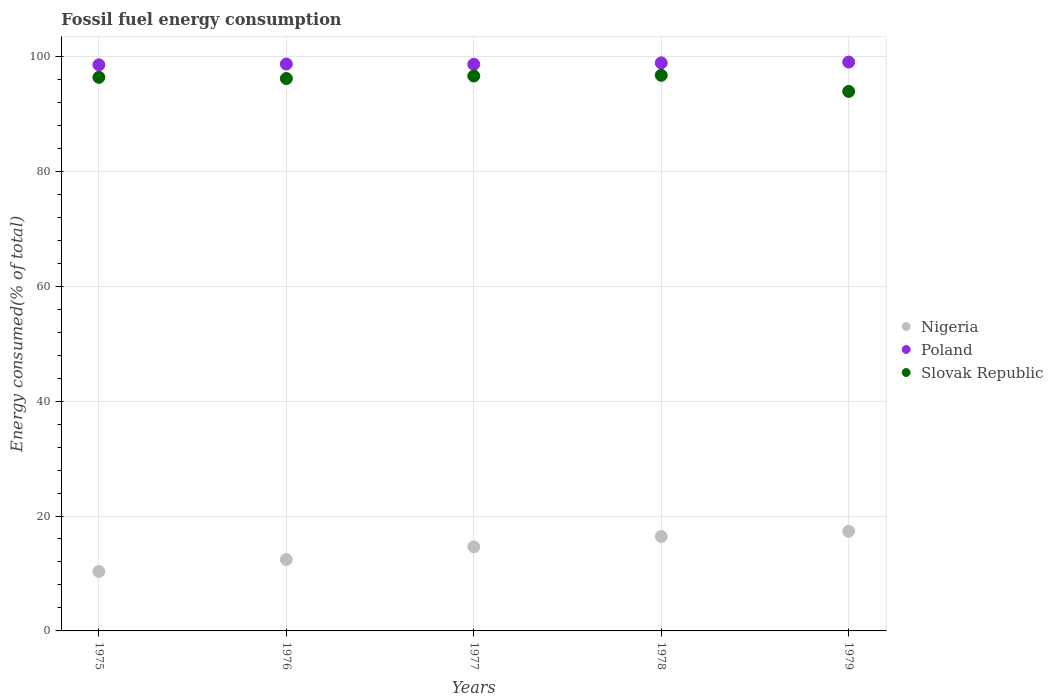How many different coloured dotlines are there?
Your response must be concise. 3. What is the percentage of energy consumed in Nigeria in 1976?
Your answer should be very brief. 12.43. Across all years, what is the maximum percentage of energy consumed in Poland?
Offer a terse response. 99.01. Across all years, what is the minimum percentage of energy consumed in Poland?
Provide a short and direct response. 98.53. In which year was the percentage of energy consumed in Poland maximum?
Offer a terse response. 1979. In which year was the percentage of energy consumed in Poland minimum?
Provide a succinct answer. 1975. What is the total percentage of energy consumed in Poland in the graph?
Give a very brief answer. 493.68. What is the difference between the percentage of energy consumed in Nigeria in 1978 and that in 1979?
Provide a short and direct response. -0.9. What is the difference between the percentage of energy consumed in Poland in 1975 and the percentage of energy consumed in Slovak Republic in 1976?
Your response must be concise. 2.39. What is the average percentage of energy consumed in Slovak Republic per year?
Offer a terse response. 95.93. In the year 1978, what is the difference between the percentage of energy consumed in Slovak Republic and percentage of energy consumed in Poland?
Your answer should be very brief. -2.16. In how many years, is the percentage of energy consumed in Poland greater than 80 %?
Provide a succinct answer. 5. What is the ratio of the percentage of energy consumed in Nigeria in 1975 to that in 1979?
Provide a short and direct response. 0.6. Is the difference between the percentage of energy consumed in Slovak Republic in 1975 and 1978 greater than the difference between the percentage of energy consumed in Poland in 1975 and 1978?
Keep it short and to the point. No. What is the difference between the highest and the second highest percentage of energy consumed in Nigeria?
Your answer should be compact. 0.9. What is the difference between the highest and the lowest percentage of energy consumed in Nigeria?
Offer a terse response. 6.98. Is the sum of the percentage of energy consumed in Slovak Republic in 1975 and 1976 greater than the maximum percentage of energy consumed in Poland across all years?
Keep it short and to the point. Yes. Is the percentage of energy consumed in Slovak Republic strictly greater than the percentage of energy consumed in Nigeria over the years?
Keep it short and to the point. Yes. How many dotlines are there?
Your answer should be very brief. 3. Where does the legend appear in the graph?
Provide a short and direct response. Center right. How many legend labels are there?
Your answer should be compact. 3. What is the title of the graph?
Your answer should be compact. Fossil fuel energy consumption. What is the label or title of the Y-axis?
Your answer should be compact. Energy consumed(% of total). What is the Energy consumed(% of total) in Nigeria in 1975?
Your response must be concise. 10.35. What is the Energy consumed(% of total) of Poland in 1975?
Your answer should be compact. 98.53. What is the Energy consumed(% of total) of Slovak Republic in 1975?
Keep it short and to the point. 96.35. What is the Energy consumed(% of total) of Nigeria in 1976?
Your answer should be compact. 12.43. What is the Energy consumed(% of total) of Poland in 1976?
Your answer should be compact. 98.66. What is the Energy consumed(% of total) in Slovak Republic in 1976?
Your response must be concise. 96.14. What is the Energy consumed(% of total) in Nigeria in 1977?
Offer a very short reply. 14.64. What is the Energy consumed(% of total) of Poland in 1977?
Your answer should be very brief. 98.62. What is the Energy consumed(% of total) of Slovak Republic in 1977?
Your response must be concise. 96.57. What is the Energy consumed(% of total) of Nigeria in 1978?
Your response must be concise. 16.44. What is the Energy consumed(% of total) in Poland in 1978?
Keep it short and to the point. 98.86. What is the Energy consumed(% of total) of Slovak Republic in 1978?
Your answer should be very brief. 96.7. What is the Energy consumed(% of total) in Nigeria in 1979?
Keep it short and to the point. 17.33. What is the Energy consumed(% of total) in Poland in 1979?
Make the answer very short. 99.01. What is the Energy consumed(% of total) in Slovak Republic in 1979?
Keep it short and to the point. 93.9. Across all years, what is the maximum Energy consumed(% of total) of Nigeria?
Offer a terse response. 17.33. Across all years, what is the maximum Energy consumed(% of total) in Poland?
Your answer should be compact. 99.01. Across all years, what is the maximum Energy consumed(% of total) of Slovak Republic?
Ensure brevity in your answer.  96.7. Across all years, what is the minimum Energy consumed(% of total) of Nigeria?
Offer a terse response. 10.35. Across all years, what is the minimum Energy consumed(% of total) of Poland?
Offer a terse response. 98.53. Across all years, what is the minimum Energy consumed(% of total) of Slovak Republic?
Provide a short and direct response. 93.9. What is the total Energy consumed(% of total) in Nigeria in the graph?
Your answer should be very brief. 71.19. What is the total Energy consumed(% of total) in Poland in the graph?
Provide a short and direct response. 493.68. What is the total Energy consumed(% of total) in Slovak Republic in the graph?
Make the answer very short. 479.66. What is the difference between the Energy consumed(% of total) of Nigeria in 1975 and that in 1976?
Keep it short and to the point. -2.08. What is the difference between the Energy consumed(% of total) in Poland in 1975 and that in 1976?
Keep it short and to the point. -0.13. What is the difference between the Energy consumed(% of total) in Slovak Republic in 1975 and that in 1976?
Your answer should be compact. 0.21. What is the difference between the Energy consumed(% of total) of Nigeria in 1975 and that in 1977?
Offer a very short reply. -4.29. What is the difference between the Energy consumed(% of total) of Poland in 1975 and that in 1977?
Provide a short and direct response. -0.09. What is the difference between the Energy consumed(% of total) of Slovak Republic in 1975 and that in 1977?
Offer a terse response. -0.23. What is the difference between the Energy consumed(% of total) of Nigeria in 1975 and that in 1978?
Keep it short and to the point. -6.09. What is the difference between the Energy consumed(% of total) in Poland in 1975 and that in 1978?
Give a very brief answer. -0.33. What is the difference between the Energy consumed(% of total) of Slovak Republic in 1975 and that in 1978?
Your response must be concise. -0.36. What is the difference between the Energy consumed(% of total) of Nigeria in 1975 and that in 1979?
Give a very brief answer. -6.98. What is the difference between the Energy consumed(% of total) of Poland in 1975 and that in 1979?
Your answer should be very brief. -0.48. What is the difference between the Energy consumed(% of total) in Slovak Republic in 1975 and that in 1979?
Offer a terse response. 2.45. What is the difference between the Energy consumed(% of total) of Nigeria in 1976 and that in 1977?
Give a very brief answer. -2.21. What is the difference between the Energy consumed(% of total) in Poland in 1976 and that in 1977?
Your response must be concise. 0.05. What is the difference between the Energy consumed(% of total) in Slovak Republic in 1976 and that in 1977?
Your answer should be very brief. -0.43. What is the difference between the Energy consumed(% of total) of Nigeria in 1976 and that in 1978?
Make the answer very short. -4.01. What is the difference between the Energy consumed(% of total) in Poland in 1976 and that in 1978?
Ensure brevity in your answer.  -0.2. What is the difference between the Energy consumed(% of total) of Slovak Republic in 1976 and that in 1978?
Offer a terse response. -0.56. What is the difference between the Energy consumed(% of total) in Nigeria in 1976 and that in 1979?
Keep it short and to the point. -4.91. What is the difference between the Energy consumed(% of total) of Poland in 1976 and that in 1979?
Offer a very short reply. -0.35. What is the difference between the Energy consumed(% of total) in Slovak Republic in 1976 and that in 1979?
Offer a terse response. 2.24. What is the difference between the Energy consumed(% of total) of Nigeria in 1977 and that in 1978?
Ensure brevity in your answer.  -1.8. What is the difference between the Energy consumed(% of total) of Poland in 1977 and that in 1978?
Your answer should be very brief. -0.24. What is the difference between the Energy consumed(% of total) of Slovak Republic in 1977 and that in 1978?
Ensure brevity in your answer.  -0.13. What is the difference between the Energy consumed(% of total) of Nigeria in 1977 and that in 1979?
Make the answer very short. -2.7. What is the difference between the Energy consumed(% of total) in Poland in 1977 and that in 1979?
Offer a terse response. -0.39. What is the difference between the Energy consumed(% of total) of Slovak Republic in 1977 and that in 1979?
Ensure brevity in your answer.  2.68. What is the difference between the Energy consumed(% of total) of Nigeria in 1978 and that in 1979?
Your response must be concise. -0.9. What is the difference between the Energy consumed(% of total) of Poland in 1978 and that in 1979?
Offer a very short reply. -0.15. What is the difference between the Energy consumed(% of total) of Slovak Republic in 1978 and that in 1979?
Give a very brief answer. 2.81. What is the difference between the Energy consumed(% of total) in Nigeria in 1975 and the Energy consumed(% of total) in Poland in 1976?
Offer a very short reply. -88.31. What is the difference between the Energy consumed(% of total) of Nigeria in 1975 and the Energy consumed(% of total) of Slovak Republic in 1976?
Offer a terse response. -85.79. What is the difference between the Energy consumed(% of total) of Poland in 1975 and the Energy consumed(% of total) of Slovak Republic in 1976?
Give a very brief answer. 2.39. What is the difference between the Energy consumed(% of total) in Nigeria in 1975 and the Energy consumed(% of total) in Poland in 1977?
Provide a succinct answer. -88.27. What is the difference between the Energy consumed(% of total) of Nigeria in 1975 and the Energy consumed(% of total) of Slovak Republic in 1977?
Keep it short and to the point. -86.22. What is the difference between the Energy consumed(% of total) in Poland in 1975 and the Energy consumed(% of total) in Slovak Republic in 1977?
Make the answer very short. 1.96. What is the difference between the Energy consumed(% of total) of Nigeria in 1975 and the Energy consumed(% of total) of Poland in 1978?
Provide a short and direct response. -88.51. What is the difference between the Energy consumed(% of total) in Nigeria in 1975 and the Energy consumed(% of total) in Slovak Republic in 1978?
Keep it short and to the point. -86.35. What is the difference between the Energy consumed(% of total) of Poland in 1975 and the Energy consumed(% of total) of Slovak Republic in 1978?
Your answer should be compact. 1.83. What is the difference between the Energy consumed(% of total) of Nigeria in 1975 and the Energy consumed(% of total) of Poland in 1979?
Provide a short and direct response. -88.66. What is the difference between the Energy consumed(% of total) in Nigeria in 1975 and the Energy consumed(% of total) in Slovak Republic in 1979?
Ensure brevity in your answer.  -83.55. What is the difference between the Energy consumed(% of total) of Poland in 1975 and the Energy consumed(% of total) of Slovak Republic in 1979?
Provide a short and direct response. 4.63. What is the difference between the Energy consumed(% of total) of Nigeria in 1976 and the Energy consumed(% of total) of Poland in 1977?
Offer a very short reply. -86.19. What is the difference between the Energy consumed(% of total) in Nigeria in 1976 and the Energy consumed(% of total) in Slovak Republic in 1977?
Your answer should be very brief. -84.15. What is the difference between the Energy consumed(% of total) in Poland in 1976 and the Energy consumed(% of total) in Slovak Republic in 1977?
Your answer should be very brief. 2.09. What is the difference between the Energy consumed(% of total) in Nigeria in 1976 and the Energy consumed(% of total) in Poland in 1978?
Your answer should be compact. -86.44. What is the difference between the Energy consumed(% of total) of Nigeria in 1976 and the Energy consumed(% of total) of Slovak Republic in 1978?
Provide a succinct answer. -84.28. What is the difference between the Energy consumed(% of total) of Poland in 1976 and the Energy consumed(% of total) of Slovak Republic in 1978?
Offer a terse response. 1.96. What is the difference between the Energy consumed(% of total) in Nigeria in 1976 and the Energy consumed(% of total) in Poland in 1979?
Ensure brevity in your answer.  -86.58. What is the difference between the Energy consumed(% of total) in Nigeria in 1976 and the Energy consumed(% of total) in Slovak Republic in 1979?
Your answer should be compact. -81.47. What is the difference between the Energy consumed(% of total) of Poland in 1976 and the Energy consumed(% of total) of Slovak Republic in 1979?
Offer a very short reply. 4.77. What is the difference between the Energy consumed(% of total) in Nigeria in 1977 and the Energy consumed(% of total) in Poland in 1978?
Keep it short and to the point. -84.22. What is the difference between the Energy consumed(% of total) in Nigeria in 1977 and the Energy consumed(% of total) in Slovak Republic in 1978?
Your answer should be very brief. -82.07. What is the difference between the Energy consumed(% of total) in Poland in 1977 and the Energy consumed(% of total) in Slovak Republic in 1978?
Your answer should be compact. 1.91. What is the difference between the Energy consumed(% of total) in Nigeria in 1977 and the Energy consumed(% of total) in Poland in 1979?
Keep it short and to the point. -84.37. What is the difference between the Energy consumed(% of total) in Nigeria in 1977 and the Energy consumed(% of total) in Slovak Republic in 1979?
Ensure brevity in your answer.  -79.26. What is the difference between the Energy consumed(% of total) in Poland in 1977 and the Energy consumed(% of total) in Slovak Republic in 1979?
Offer a very short reply. 4.72. What is the difference between the Energy consumed(% of total) of Nigeria in 1978 and the Energy consumed(% of total) of Poland in 1979?
Provide a succinct answer. -82.57. What is the difference between the Energy consumed(% of total) of Nigeria in 1978 and the Energy consumed(% of total) of Slovak Republic in 1979?
Provide a succinct answer. -77.46. What is the difference between the Energy consumed(% of total) of Poland in 1978 and the Energy consumed(% of total) of Slovak Republic in 1979?
Your answer should be very brief. 4.97. What is the average Energy consumed(% of total) in Nigeria per year?
Offer a very short reply. 14.24. What is the average Energy consumed(% of total) in Poland per year?
Ensure brevity in your answer.  98.74. What is the average Energy consumed(% of total) in Slovak Republic per year?
Your response must be concise. 95.93. In the year 1975, what is the difference between the Energy consumed(% of total) of Nigeria and Energy consumed(% of total) of Poland?
Give a very brief answer. -88.18. In the year 1975, what is the difference between the Energy consumed(% of total) of Nigeria and Energy consumed(% of total) of Slovak Republic?
Ensure brevity in your answer.  -86. In the year 1975, what is the difference between the Energy consumed(% of total) in Poland and Energy consumed(% of total) in Slovak Republic?
Offer a very short reply. 2.18. In the year 1976, what is the difference between the Energy consumed(% of total) in Nigeria and Energy consumed(% of total) in Poland?
Your response must be concise. -86.24. In the year 1976, what is the difference between the Energy consumed(% of total) in Nigeria and Energy consumed(% of total) in Slovak Republic?
Offer a terse response. -83.71. In the year 1976, what is the difference between the Energy consumed(% of total) of Poland and Energy consumed(% of total) of Slovak Republic?
Your answer should be very brief. 2.52. In the year 1977, what is the difference between the Energy consumed(% of total) in Nigeria and Energy consumed(% of total) in Poland?
Provide a succinct answer. -83.98. In the year 1977, what is the difference between the Energy consumed(% of total) of Nigeria and Energy consumed(% of total) of Slovak Republic?
Give a very brief answer. -81.94. In the year 1977, what is the difference between the Energy consumed(% of total) of Poland and Energy consumed(% of total) of Slovak Republic?
Your answer should be very brief. 2.04. In the year 1978, what is the difference between the Energy consumed(% of total) in Nigeria and Energy consumed(% of total) in Poland?
Ensure brevity in your answer.  -82.42. In the year 1978, what is the difference between the Energy consumed(% of total) in Nigeria and Energy consumed(% of total) in Slovak Republic?
Offer a very short reply. -80.27. In the year 1978, what is the difference between the Energy consumed(% of total) of Poland and Energy consumed(% of total) of Slovak Republic?
Ensure brevity in your answer.  2.16. In the year 1979, what is the difference between the Energy consumed(% of total) in Nigeria and Energy consumed(% of total) in Poland?
Keep it short and to the point. -81.67. In the year 1979, what is the difference between the Energy consumed(% of total) of Nigeria and Energy consumed(% of total) of Slovak Republic?
Ensure brevity in your answer.  -76.56. In the year 1979, what is the difference between the Energy consumed(% of total) in Poland and Energy consumed(% of total) in Slovak Republic?
Your answer should be very brief. 5.11. What is the ratio of the Energy consumed(% of total) of Nigeria in 1975 to that in 1976?
Your answer should be compact. 0.83. What is the ratio of the Energy consumed(% of total) of Slovak Republic in 1975 to that in 1976?
Give a very brief answer. 1. What is the ratio of the Energy consumed(% of total) in Nigeria in 1975 to that in 1977?
Your response must be concise. 0.71. What is the ratio of the Energy consumed(% of total) in Slovak Republic in 1975 to that in 1977?
Offer a terse response. 1. What is the ratio of the Energy consumed(% of total) in Nigeria in 1975 to that in 1978?
Your answer should be very brief. 0.63. What is the ratio of the Energy consumed(% of total) of Nigeria in 1975 to that in 1979?
Offer a terse response. 0.6. What is the ratio of the Energy consumed(% of total) of Poland in 1975 to that in 1979?
Give a very brief answer. 1. What is the ratio of the Energy consumed(% of total) in Slovak Republic in 1975 to that in 1979?
Offer a very short reply. 1.03. What is the ratio of the Energy consumed(% of total) of Nigeria in 1976 to that in 1977?
Offer a terse response. 0.85. What is the ratio of the Energy consumed(% of total) in Poland in 1976 to that in 1977?
Offer a terse response. 1. What is the ratio of the Energy consumed(% of total) of Slovak Republic in 1976 to that in 1977?
Offer a terse response. 1. What is the ratio of the Energy consumed(% of total) of Nigeria in 1976 to that in 1978?
Keep it short and to the point. 0.76. What is the ratio of the Energy consumed(% of total) in Poland in 1976 to that in 1978?
Ensure brevity in your answer.  1. What is the ratio of the Energy consumed(% of total) of Nigeria in 1976 to that in 1979?
Offer a terse response. 0.72. What is the ratio of the Energy consumed(% of total) of Poland in 1976 to that in 1979?
Provide a short and direct response. 1. What is the ratio of the Energy consumed(% of total) in Slovak Republic in 1976 to that in 1979?
Give a very brief answer. 1.02. What is the ratio of the Energy consumed(% of total) of Nigeria in 1977 to that in 1978?
Offer a very short reply. 0.89. What is the ratio of the Energy consumed(% of total) of Slovak Republic in 1977 to that in 1978?
Your answer should be very brief. 1. What is the ratio of the Energy consumed(% of total) of Nigeria in 1977 to that in 1979?
Make the answer very short. 0.84. What is the ratio of the Energy consumed(% of total) of Poland in 1977 to that in 1979?
Ensure brevity in your answer.  1. What is the ratio of the Energy consumed(% of total) of Slovak Republic in 1977 to that in 1979?
Give a very brief answer. 1.03. What is the ratio of the Energy consumed(% of total) in Nigeria in 1978 to that in 1979?
Ensure brevity in your answer.  0.95. What is the ratio of the Energy consumed(% of total) of Slovak Republic in 1978 to that in 1979?
Give a very brief answer. 1.03. What is the difference between the highest and the second highest Energy consumed(% of total) of Nigeria?
Provide a succinct answer. 0.9. What is the difference between the highest and the second highest Energy consumed(% of total) in Poland?
Your response must be concise. 0.15. What is the difference between the highest and the second highest Energy consumed(% of total) of Slovak Republic?
Your answer should be very brief. 0.13. What is the difference between the highest and the lowest Energy consumed(% of total) in Nigeria?
Your response must be concise. 6.98. What is the difference between the highest and the lowest Energy consumed(% of total) of Poland?
Offer a terse response. 0.48. What is the difference between the highest and the lowest Energy consumed(% of total) in Slovak Republic?
Your answer should be very brief. 2.81. 